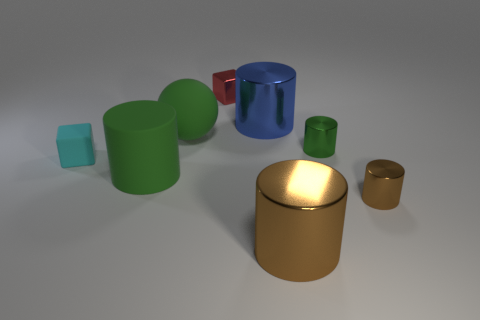Subtract all yellow cubes. How many green cylinders are left? 2 Subtract all green matte cylinders. How many cylinders are left? 4 Subtract all brown cylinders. How many cylinders are left? 3 Subtract 3 cylinders. How many cylinders are left? 2 Add 1 large shiny cylinders. How many objects exist? 9 Subtract all spheres. How many objects are left? 7 Subtract all red cylinders. Subtract all cyan blocks. How many cylinders are left? 5 Subtract 0 gray cylinders. How many objects are left? 8 Subtract all small green cylinders. Subtract all large green matte cylinders. How many objects are left? 6 Add 1 tiny objects. How many tiny objects are left? 5 